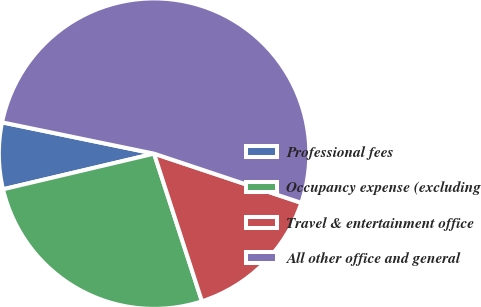Convert chart. <chart><loc_0><loc_0><loc_500><loc_500><pie_chart><fcel>Professional fees<fcel>Occupancy expense (excluding<fcel>Travel & entertainment office<fcel>All other office and general<nl><fcel>6.92%<fcel>26.3%<fcel>14.88%<fcel>51.9%<nl></chart> 